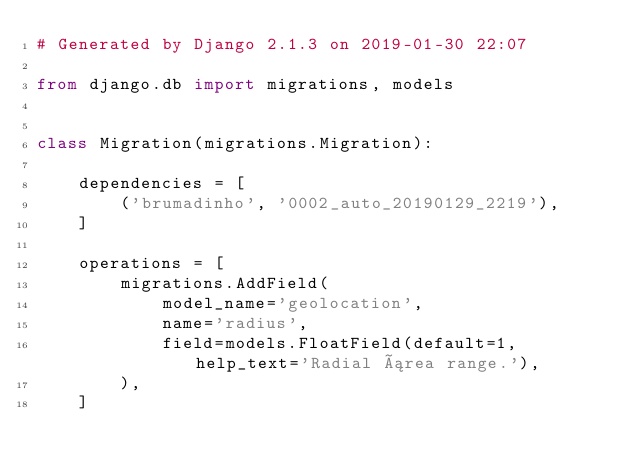<code> <loc_0><loc_0><loc_500><loc_500><_Python_># Generated by Django 2.1.3 on 2019-01-30 22:07

from django.db import migrations, models


class Migration(migrations.Migration):

    dependencies = [
        ('brumadinho', '0002_auto_20190129_2219'),
    ]

    operations = [
        migrations.AddField(
            model_name='geolocation',
            name='radius',
            field=models.FloatField(default=1, help_text='Radial área range.'),
        ),
    ]
</code> 